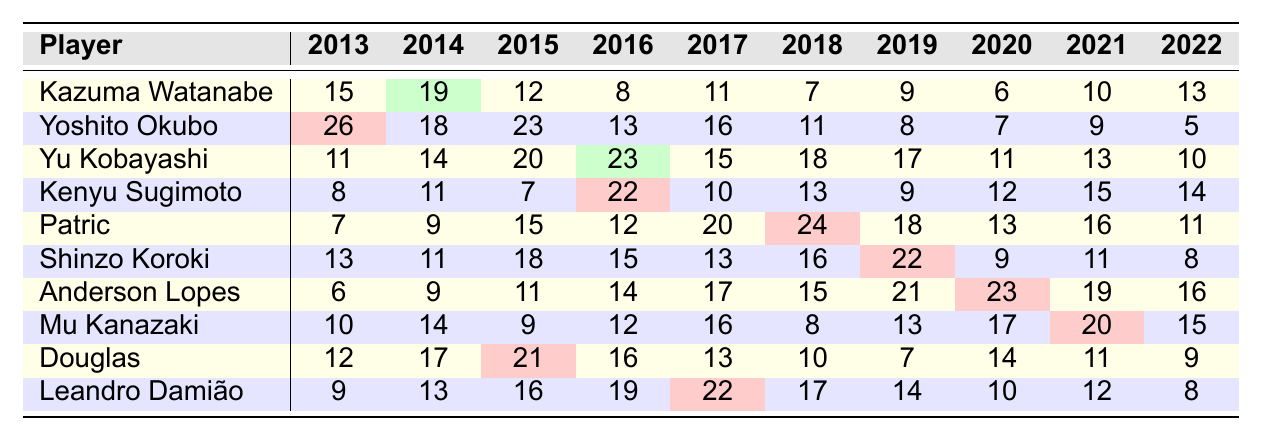What is the highest number of goals scored by a player in a single season from 2013 to 2022? By examining the table, we find that Yoshito Okubo scored 26 goals in 2013, which is the highest value among all players and seasons displayed.
Answer: 26 Which player has the most consistent scoring over the years, scoring at least 10 goals in most seasons? By reviewing the goals per season, both Yu Kobayashi and Patric consistently scored at least 10 goals from 2015 to 2022, but only Patric did so for all seasons since 2014. Thus, Patric exhibits the most consistency with his goal-scoring.
Answer: Patric What is the sum of Kenyu Sugimoto's goals from 2013 to 2022? To find the sum, we add all of Kenyu Sugimoto's goals: 8 + 11 + 7 + 22 + 10 + 13 + 9 + 12 + 15 + 14 =  8 + 11 = 19, 19 + 7 = 26, 26 + 22 = 48, 48 + 10 = 58, 58 + 13 = 71, 71 + 9 = 80, 80 + 12 = 92, 92 + 15 = 107, 107 + 14 = 121. The total is 121.
Answer: 121 In which year did Patric score his highest goal tally, and how many goals did he score that season? Looking at Patric's row, we see he achieved his highest tally with 24 goals in the 2018 season.
Answer: 2018, 24 Is there a player who scored more than 20 goals in at least two different seasons? Upon reviewing the table, Yu Kobayashi scored over 20 goals in 2015 (20) and 2016 (23), and Patric scored over 20 goals in both 2017 (20) and 2018 (24). Thus, both players fulfilled the requirement.
Answer: Yes What is the average number of goals scored by Leandro Damião over the seasons? To calculate the average, we first sum his goals: 9 + 13 + 16 + 19 + 22 + 17 + 14 + 10 + 12 + 8 = 10 + 22 + 16 + 19 + 22 + 17 + 14 + 10 + 12 + 8 = 133. There are 10 seasons, so dividing by 10 gives us 133/10 = 13.3.
Answer: 13.3 Which season saw the overall highest total number of goals when combining the top scorers' performances? Summing up the number of goals for all players in each season, we can find the total goals per season. The calculations show that 2014 had the highest total with all players: 19 + 18 + 14 + 11 + 9 + 11 + 9 + 14 + 17 + 13 = 142.
Answer: 2014 